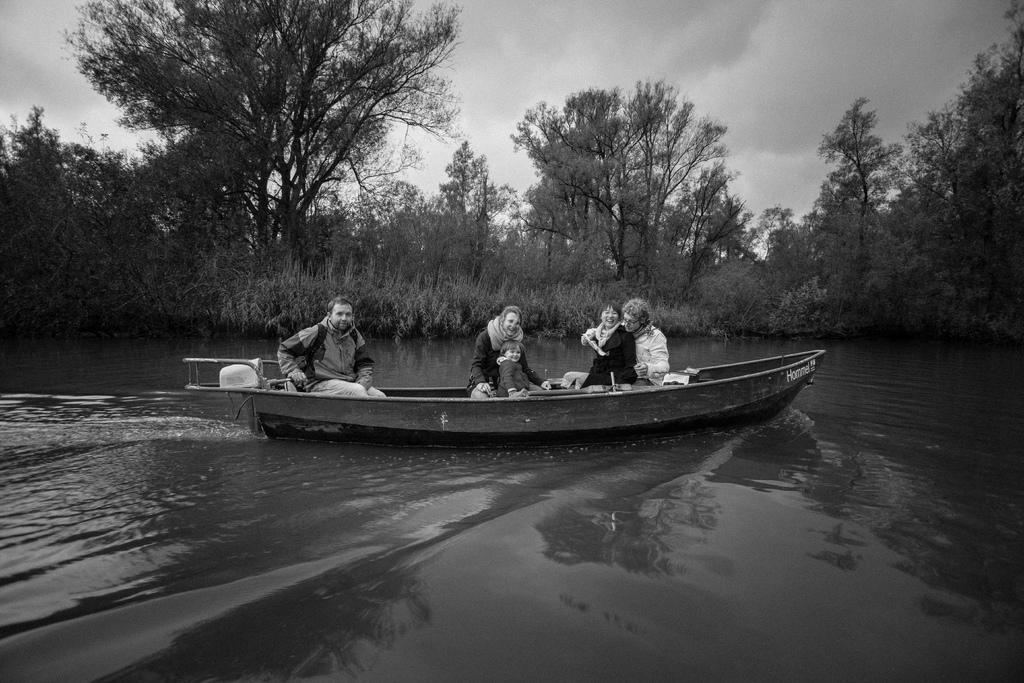Please provide a concise description of this image. In this image in the middle there is a boat on that there are some people, on the left there is a man, he wears a jacket, trouser. In the middle there is a woman, she wears a jacket, in front of her there is a child. On the right there are two people. At the bottom there are waves, water. In the background there are trees, plants, sky and clouds. 